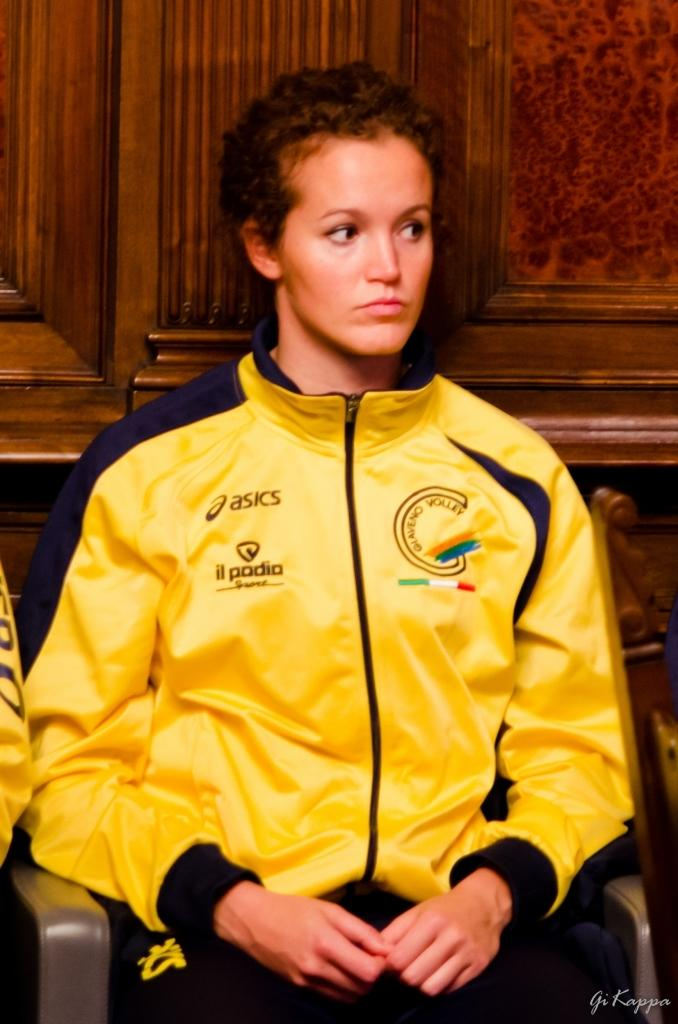<image>
Share a concise interpretation of the image provided. A woman in an asics jacket sits in a chair in front of a wood-paneled wall. 